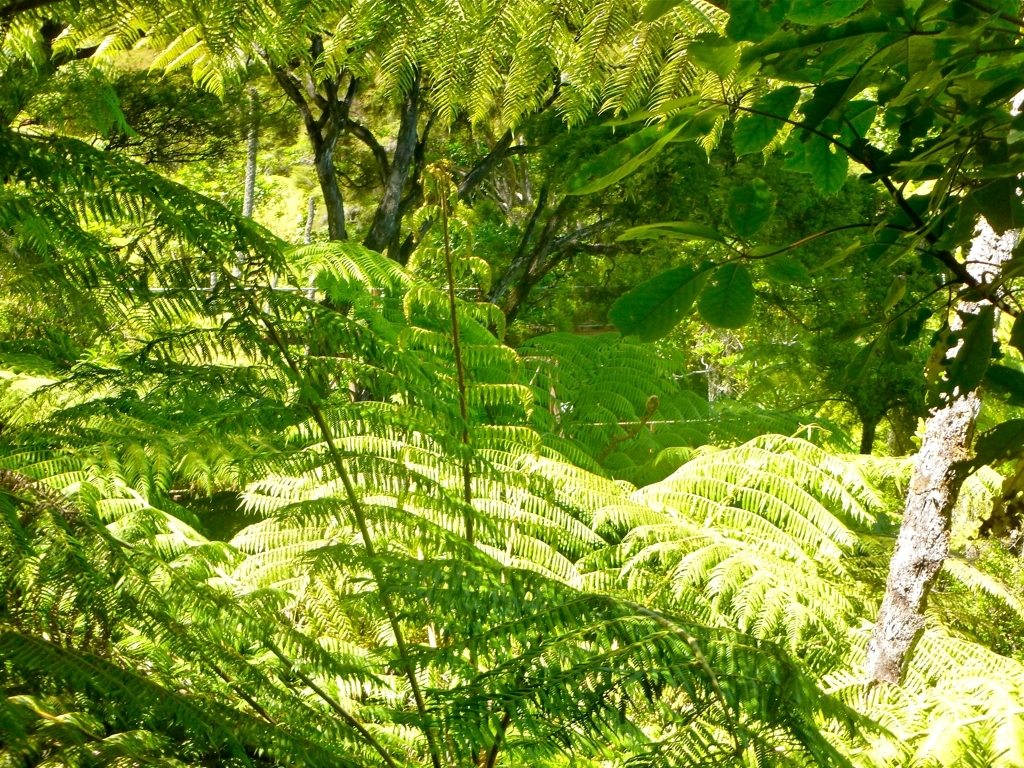This looks like a peaceful place. Could you describe what it might feel like to be there? Being there might feel quite serene and refreshing. You'd likely experience the coolness of the shade provided by the lush canopy, the soft rustle of leaves stirred by a gentle breeze, and perhaps the distant sound of wildlife or a nearby stream. The air would be fresh, possibly moist, and filled with the earthy aroma of rich vegetation. It's an environment that seems to invite quiet reflection and a deep connection with nature. 